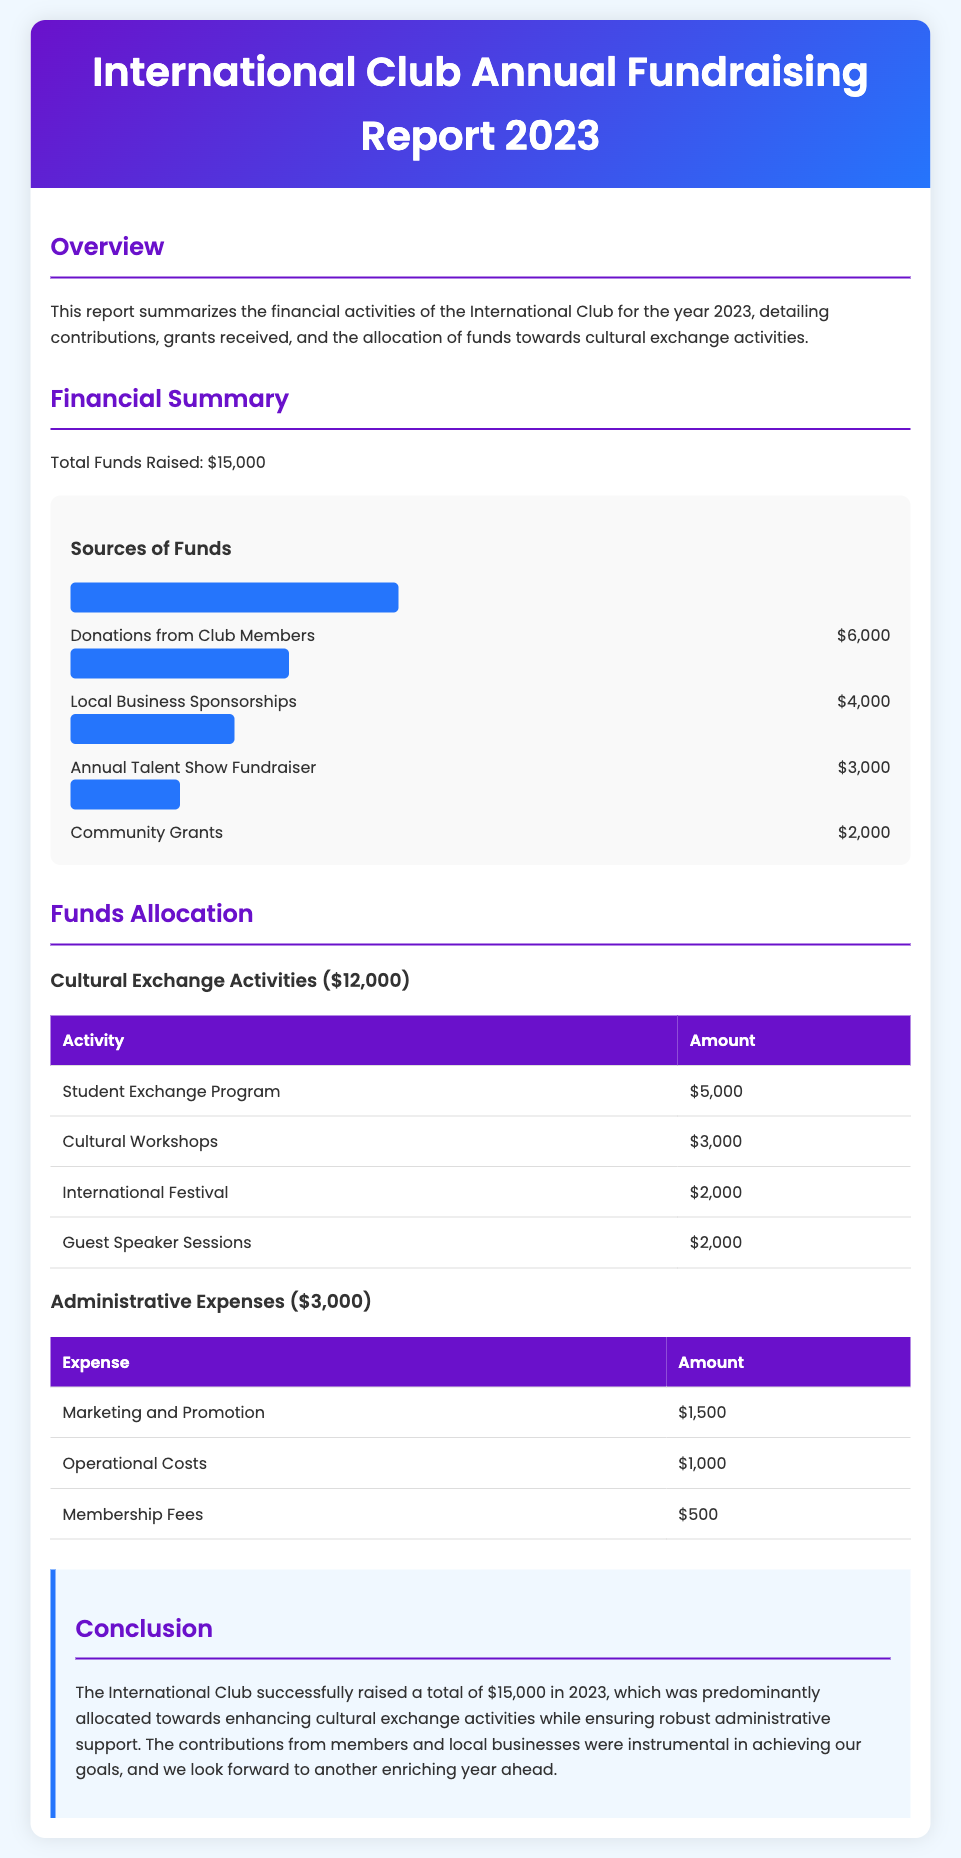what is the total funds raised? The total funds raised is clearly stated in the financial summary section of the document as $15,000.
Answer: $15,000 how much was raised from donations? Donations from club members contributed $6,000, according to the sources of funds chart.
Answer: $6,000 what is the allocation for the Student Exchange Program? The document specifies that $5,000 was allocated for the Student Exchange Program.
Answer: $5,000 which activity received the least funding? The Community Grants section outlines that it received $2,000, which is the least among listed activities.
Answer: $2,000 what percentage of the total funds was spent on cultural exchange activities? The funds allocated for cultural exchange activities are $12,000, which is 80% of the total funds raised of $15,000.
Answer: 80% how much funding did local business sponsorships provide? The local business sponsorships provided $4,000, as shown in the sources of funds section.
Answer: $4,000 what are the total administrative expenses? The total for administrative expenses is listed as $3,000 in the funds allocation section.
Answer: $3,000 what was the amount allocated for cultural workshops? The amount allocated for Cultural Workshops is clearly stated as $3,000 in the funds allocation section.
Answer: $3,000 how many guest speaker sessions were funded? The document indicates that $2,000 was allocated for Guest Speaker Sessions.
Answer: $2,000 